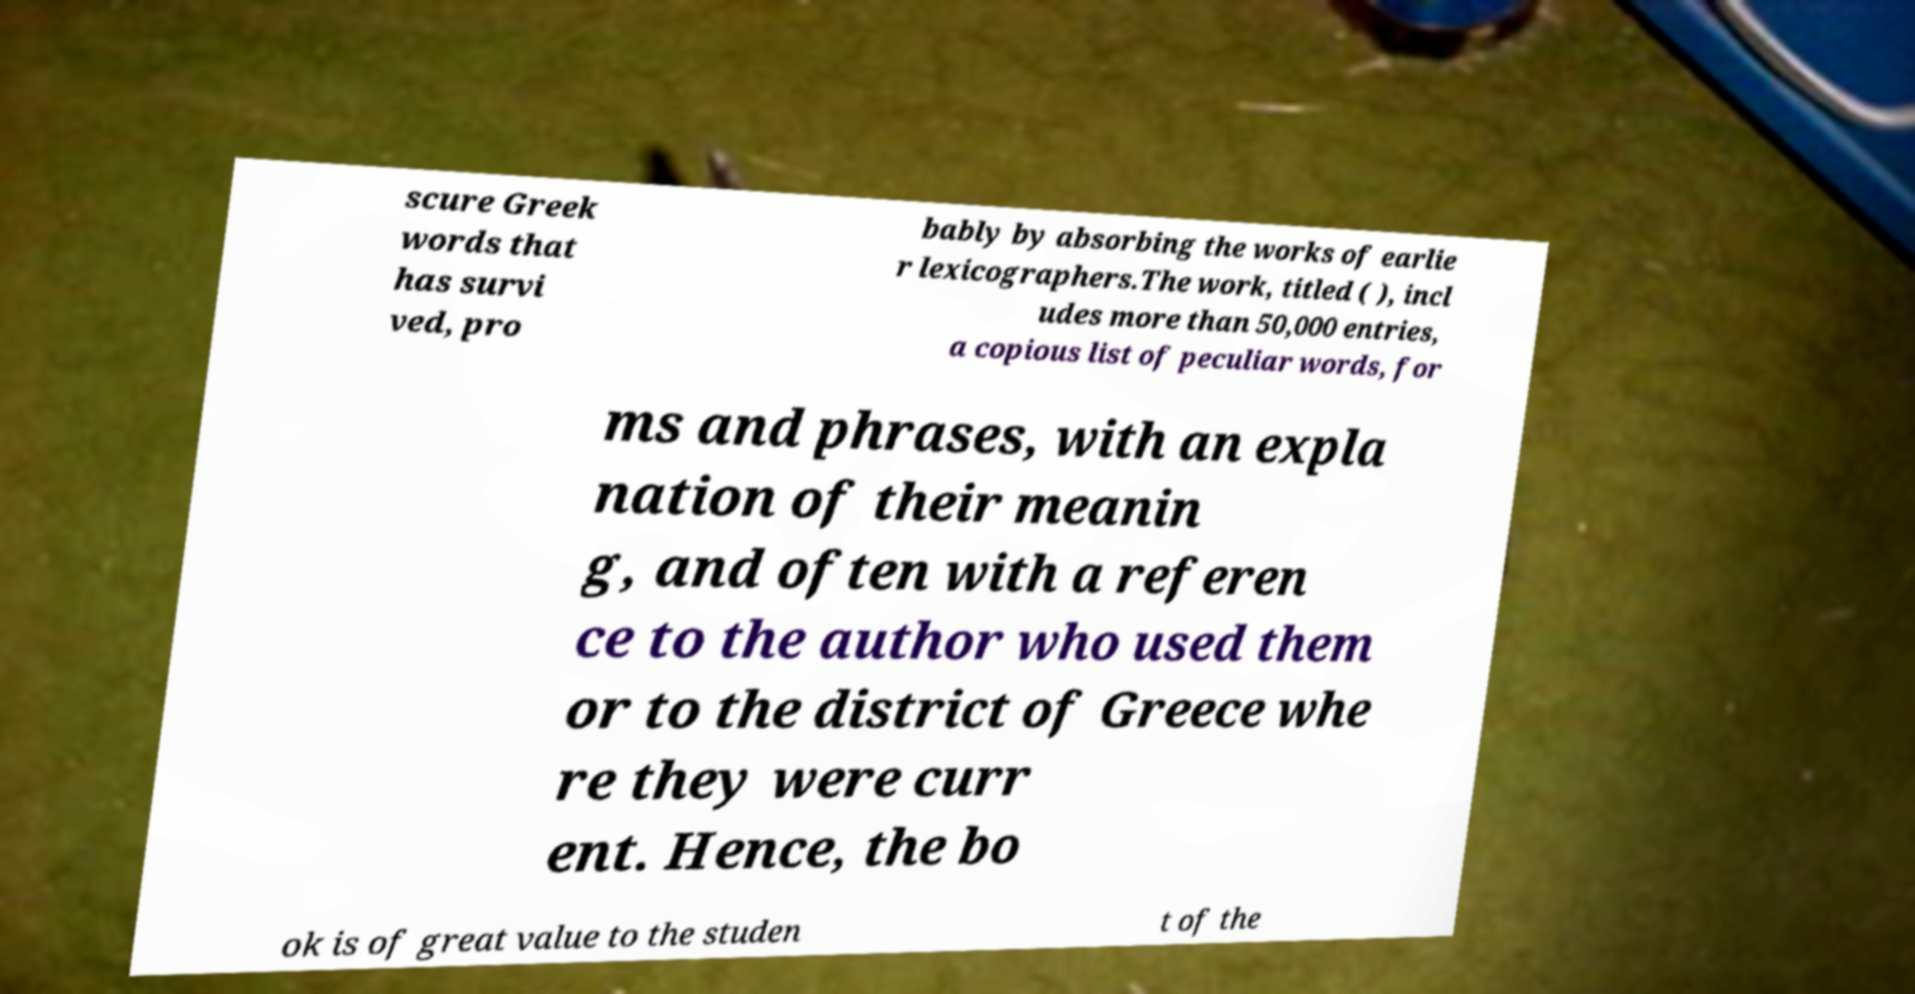Please read and relay the text visible in this image. What does it say? scure Greek words that has survi ved, pro bably by absorbing the works of earlie r lexicographers.The work, titled ( ), incl udes more than 50,000 entries, a copious list of peculiar words, for ms and phrases, with an expla nation of their meanin g, and often with a referen ce to the author who used them or to the district of Greece whe re they were curr ent. Hence, the bo ok is of great value to the studen t of the 